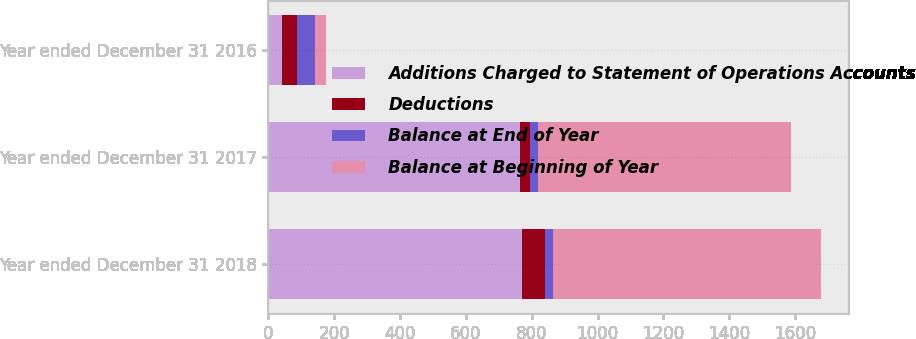Convert chart to OTSL. <chart><loc_0><loc_0><loc_500><loc_500><stacked_bar_chart><ecel><fcel>Year ended December 31 2018<fcel>Year ended December 31 2017<fcel>Year ended December 31 2016<nl><fcel>Additions Charged to Statement of Operations Accounts<fcel>769<fcel>765<fcel>41<nl><fcel>Deductions<fcel>70<fcel>29<fcel>47<nl><fcel>Balance at End of Year<fcel>25<fcel>25<fcel>52<nl><fcel>Balance at Beginning of Year<fcel>814<fcel>769<fcel>36<nl></chart> 